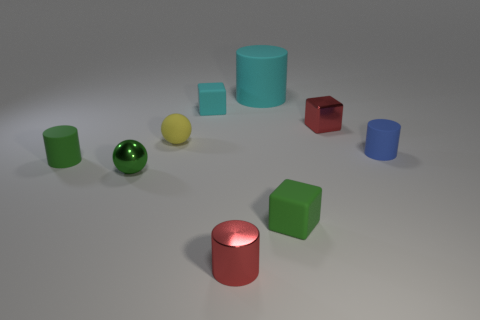There is a large matte cylinder; how many spheres are behind it? 0 